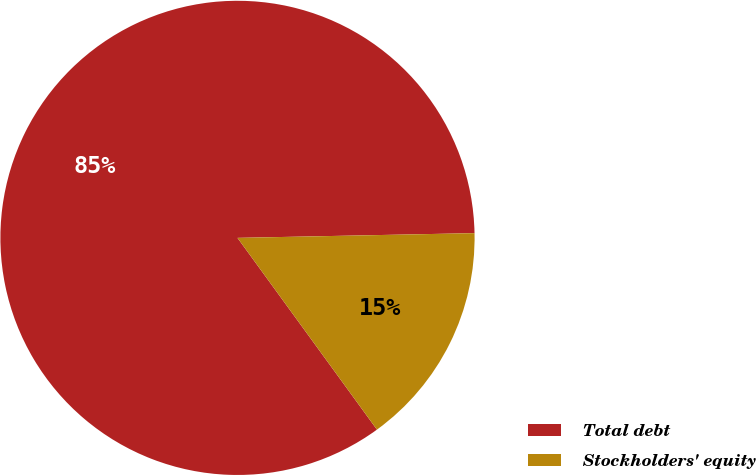<chart> <loc_0><loc_0><loc_500><loc_500><pie_chart><fcel>Total debt<fcel>Stockholders' equity<nl><fcel>84.69%<fcel>15.31%<nl></chart> 